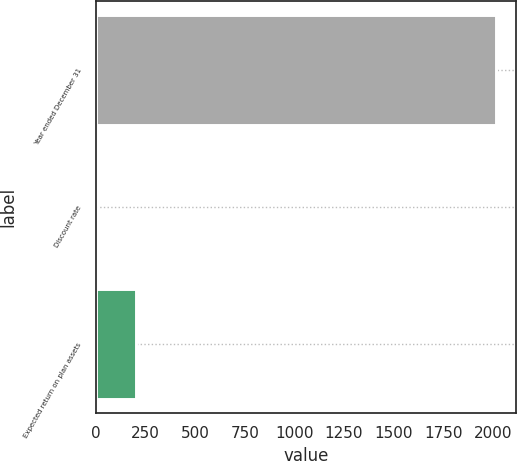Convert chart to OTSL. <chart><loc_0><loc_0><loc_500><loc_500><bar_chart><fcel>Year ended December 31<fcel>Discount rate<fcel>Expected return on plan assets<nl><fcel>2018<fcel>3.25<fcel>204.73<nl></chart> 